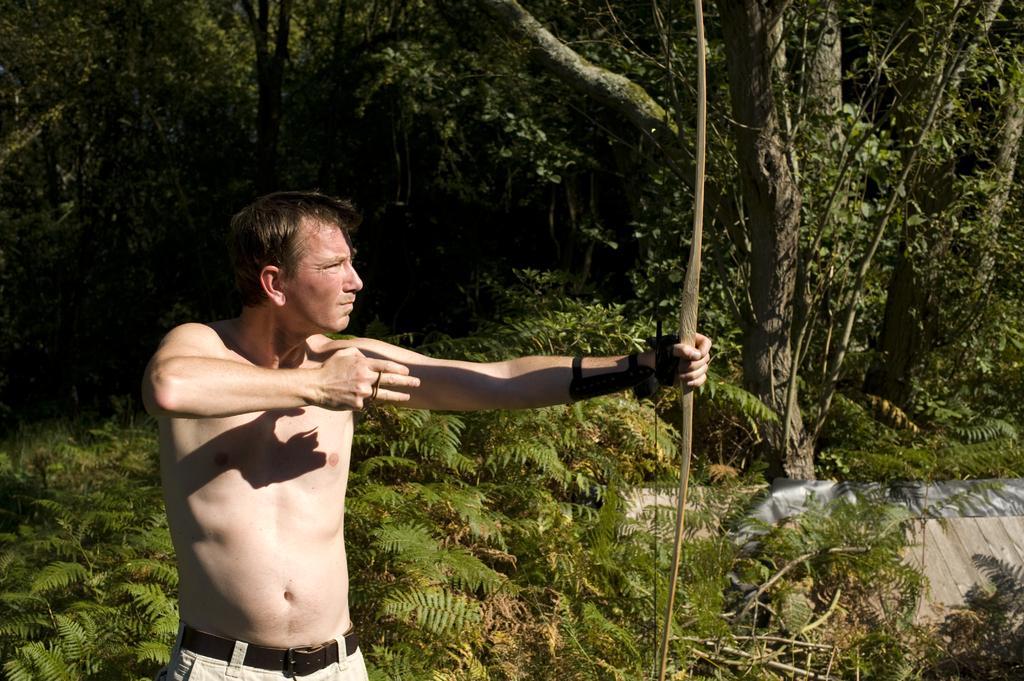In one or two sentences, can you explain what this image depicts? In this image there is a man in the middle who is without the shirt. He is holding the bow. In the background there are trees. At the bottom there are small plants and a wall on the right side bottom. 